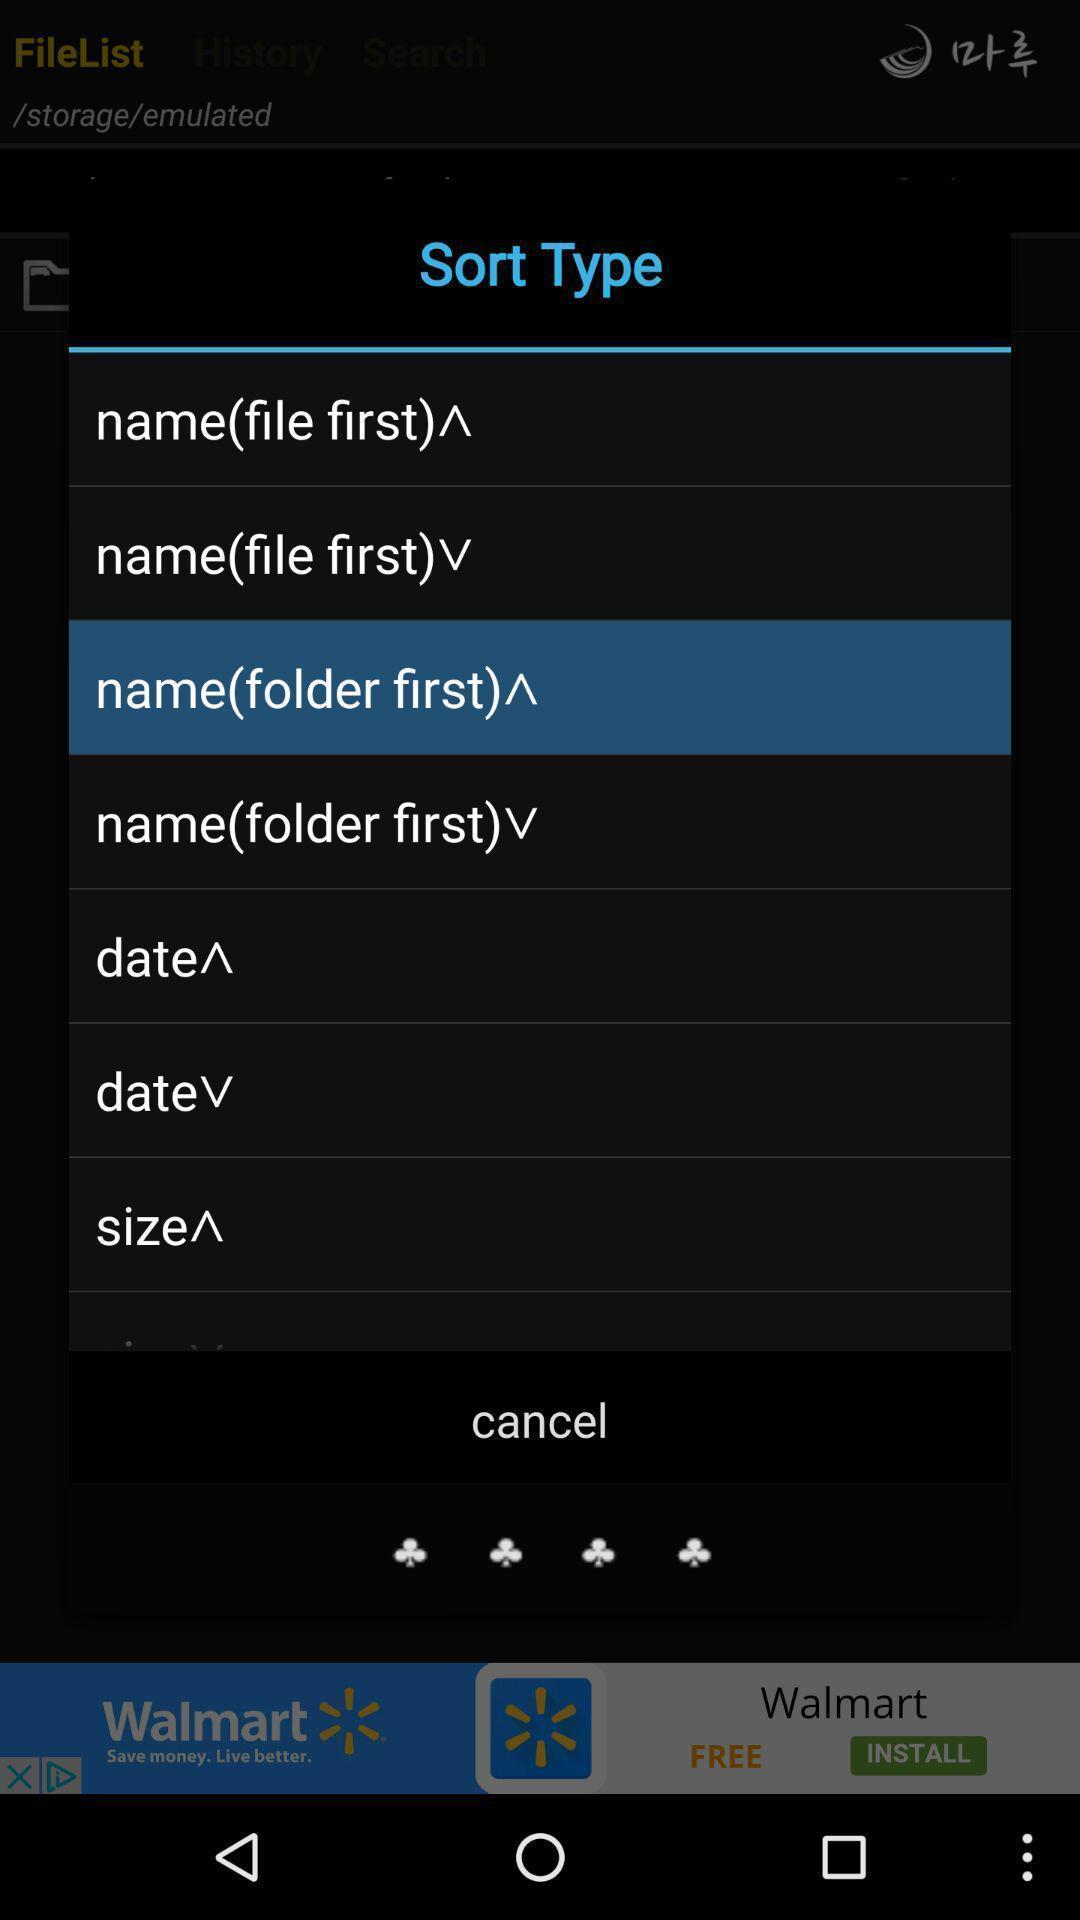Provide a detailed account of this screenshot. Popup showing few options. 